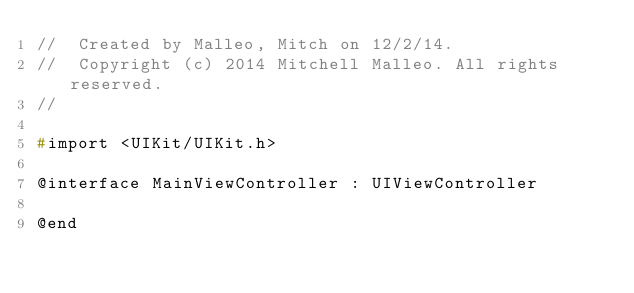Convert code to text. <code><loc_0><loc_0><loc_500><loc_500><_C_>//  Created by Malleo, Mitch on 12/2/14.
//  Copyright (c) 2014 Mitchell Malleo. All rights reserved.
//

#import <UIKit/UIKit.h>

@interface MainViewController : UIViewController

@end
</code> 